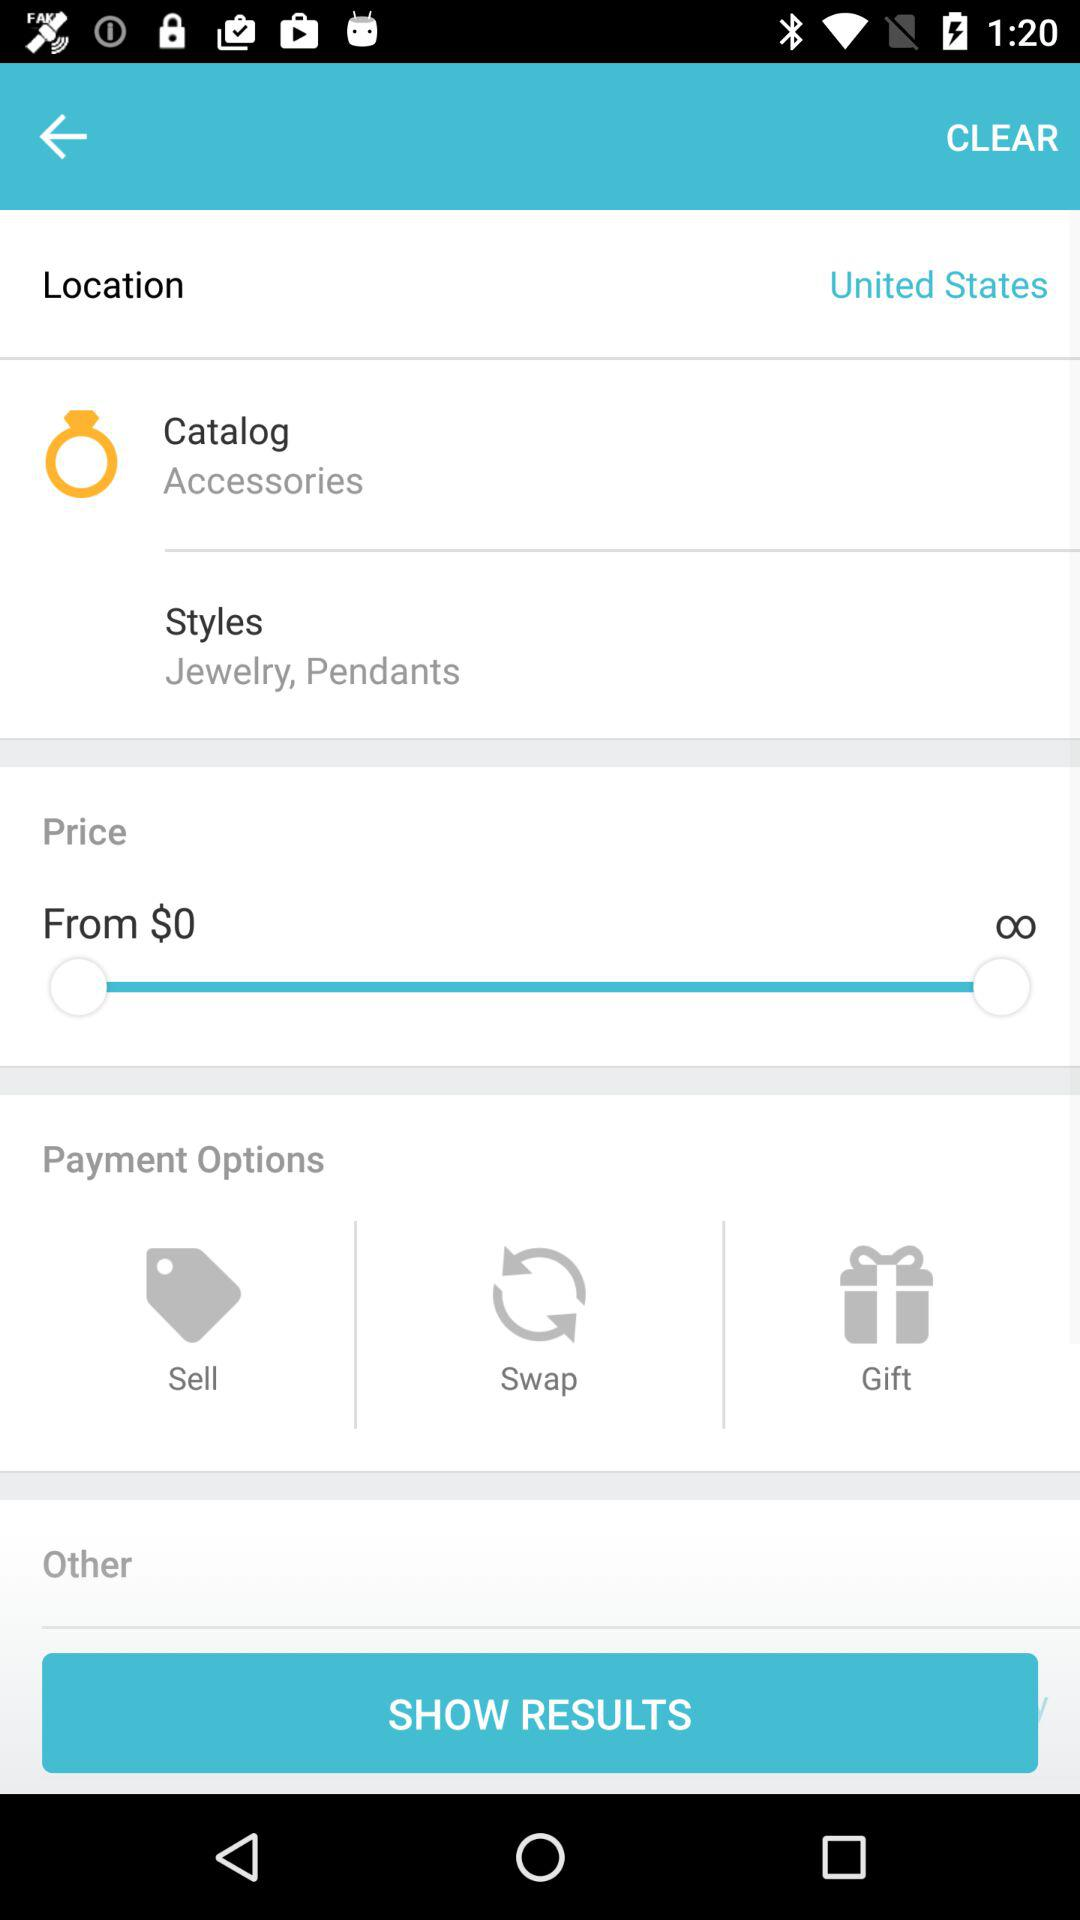What is the selected catalog? The selected catalog is "Accessories". 